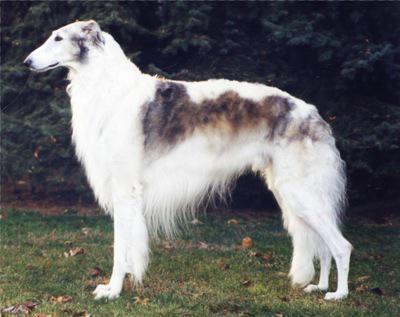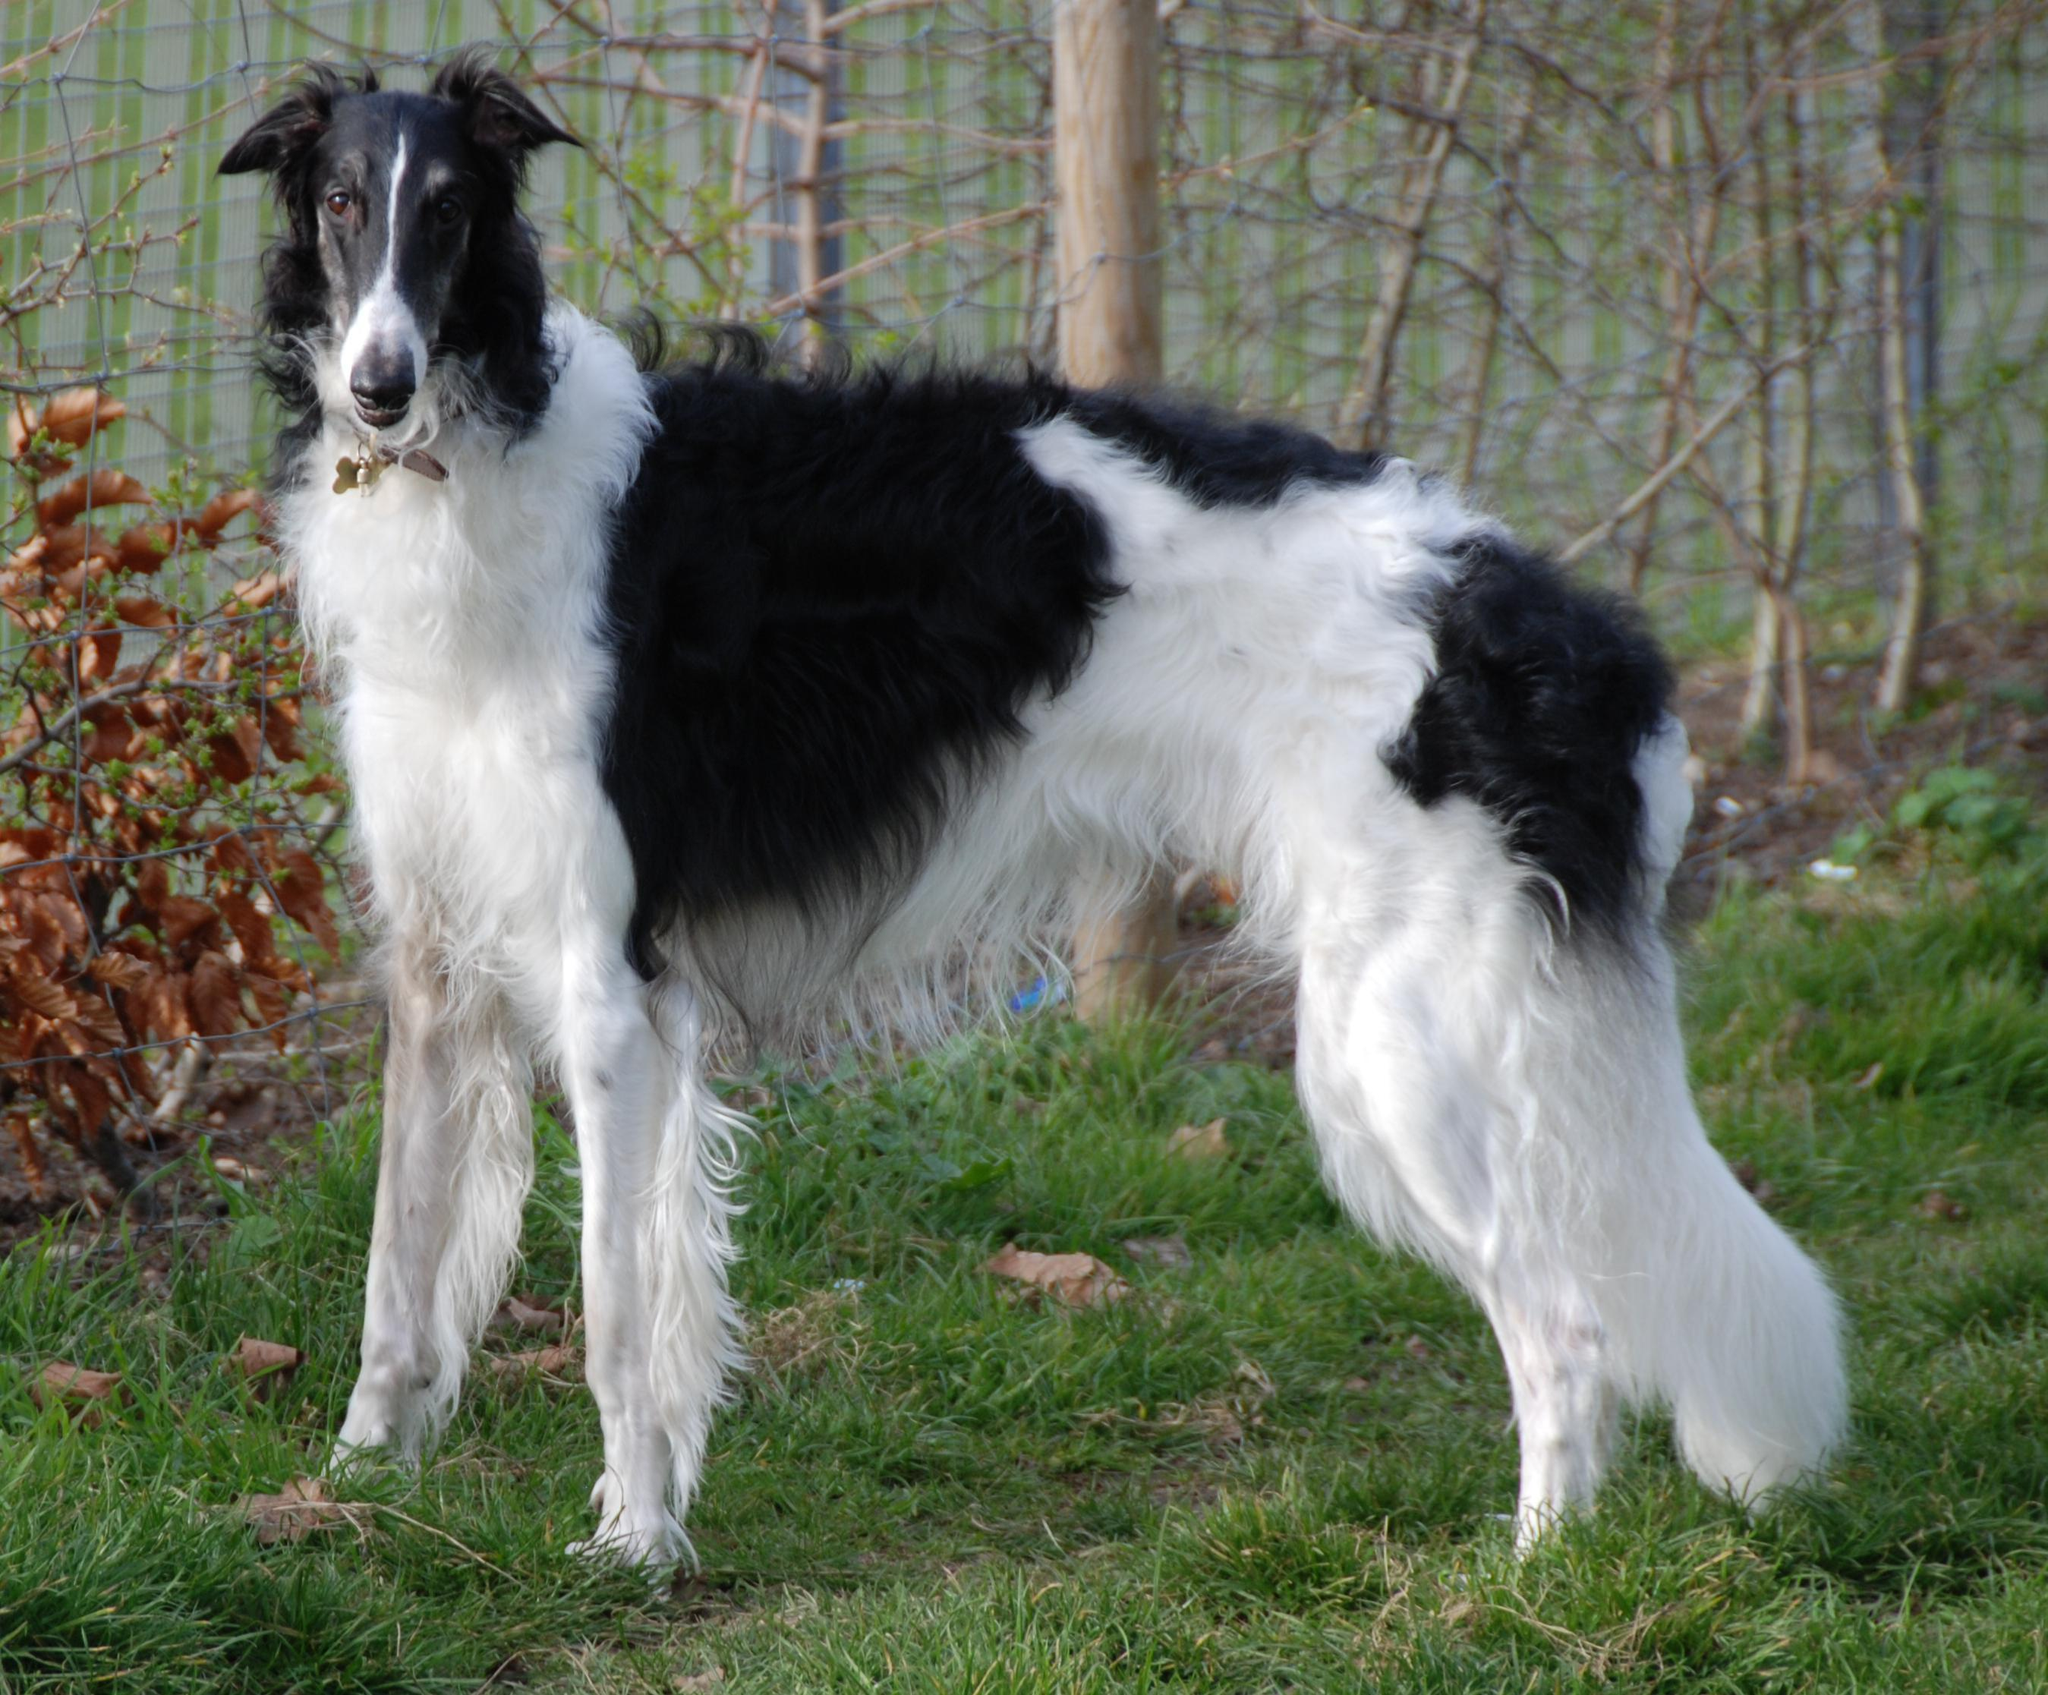The first image is the image on the left, the second image is the image on the right. Examine the images to the left and right. Is the description "Two dogs are pictured facing each other." accurate? Answer yes or no. No. The first image is the image on the left, the second image is the image on the right. Analyze the images presented: Is the assertion "The hounds in the two images face in the general direction toward each other." valid? Answer yes or no. No. 